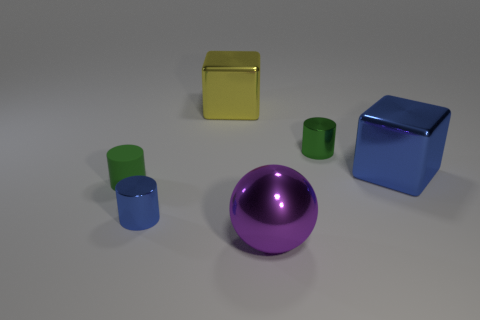Add 1 gray rubber balls. How many objects exist? 7 Subtract all blocks. How many objects are left? 4 Subtract all green rubber cylinders. Subtract all small cylinders. How many objects are left? 2 Add 1 yellow cubes. How many yellow cubes are left? 2 Add 4 tiny red rubber blocks. How many tiny red rubber blocks exist? 4 Subtract 0 yellow balls. How many objects are left? 6 